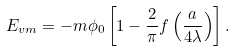Convert formula to latex. <formula><loc_0><loc_0><loc_500><loc_500>E _ { v m } = - m \phi _ { 0 } \left [ 1 - \frac { 2 } { \pi } f \left ( \frac { a } { 4 \lambda } \right ) \right ] .</formula> 